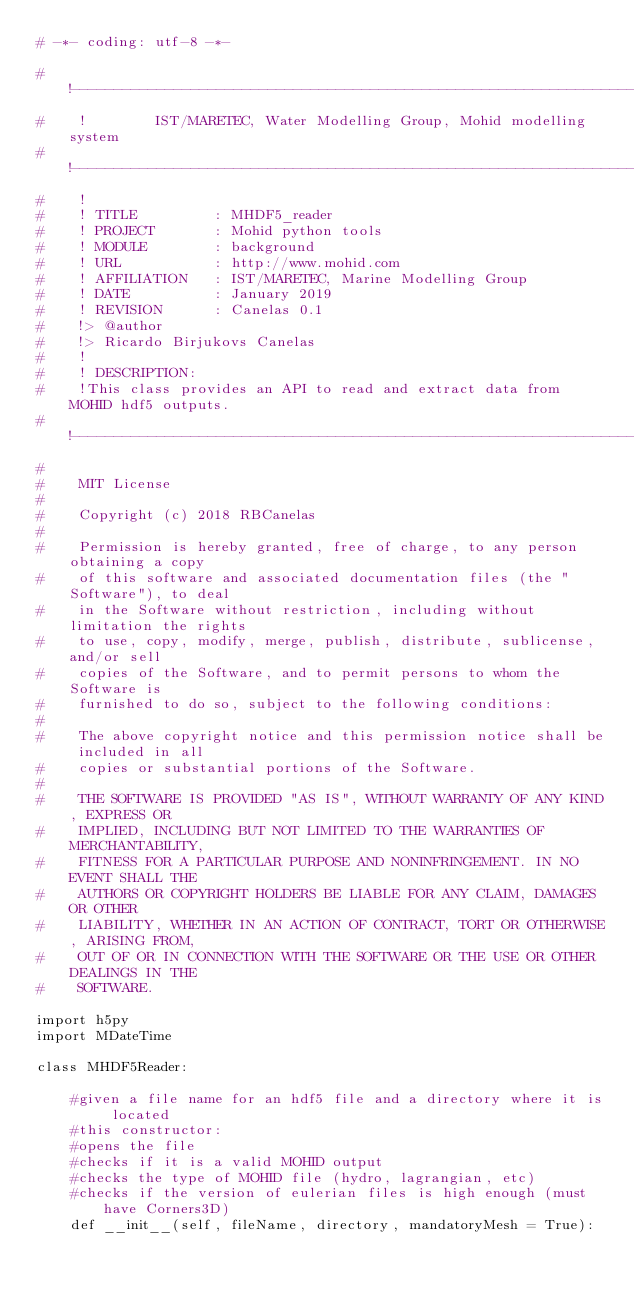Convert code to text. <code><loc_0><loc_0><loc_500><loc_500><_Python_># -*- coding: utf-8 -*-

#    !------------------------------------------------------------------------------
#    !        IST/MARETEC, Water Modelling Group, Mohid modelling system
#    !------------------------------------------------------------------------------
#    !
#    ! TITLE         : MHDF5_reader
#    ! PROJECT       : Mohid python tools
#    ! MODULE        : background
#    ! URL           : http://www.mohid.com
#    ! AFFILIATION   : IST/MARETEC, Marine Modelling Group
#    ! DATE          : January 2019
#    ! REVISION      : Canelas 0.1
#    !> @author
#    !> Ricardo Birjukovs Canelas
#    !
#    ! DESCRIPTION:
#    !This class provides an API to read and extract data from MOHID hdf5 outputs.
#    !------------------------------------------------------------------------------
#    
#    MIT License
#    
#    Copyright (c) 2018 RBCanelas
#    
#    Permission is hereby granted, free of charge, to any person obtaining a copy
#    of this software and associated documentation files (the "Software"), to deal
#    in the Software without restriction, including without limitation the rights
#    to use, copy, modify, merge, publish, distribute, sublicense, and/or sell
#    copies of the Software, and to permit persons to whom the Software is
#    furnished to do so, subject to the following conditions:
#    
#    The above copyright notice and this permission notice shall be included in all
#    copies or substantial portions of the Software.
#    
#    THE SOFTWARE IS PROVIDED "AS IS", WITHOUT WARRANTY OF ANY KIND, EXPRESS OR
#    IMPLIED, INCLUDING BUT NOT LIMITED TO THE WARRANTIES OF MERCHANTABILITY,
#    FITNESS FOR A PARTICULAR PURPOSE AND NONINFRINGEMENT. IN NO EVENT SHALL THE
#    AUTHORS OR COPYRIGHT HOLDERS BE LIABLE FOR ANY CLAIM, DAMAGES OR OTHER
#    LIABILITY, WHETHER IN AN ACTION OF CONTRACT, TORT OR OTHERWISE, ARISING FROM,
#    OUT OF OR IN CONNECTION WITH THE SOFTWARE OR THE USE OR OTHER DEALINGS IN THE
#    SOFTWARE.

import h5py
import MDateTime

class MHDF5Reader:
    
    #given a file name for an hdf5 file and a directory where it is located
    #this constructor: 
    #opens the file
    #checks if it is a valid MOHID output
    #checks the type of MOHID file (hydro, lagrangian, etc)
    #checks if the version of eulerian files is high enough (must have Corners3D) 
    def __init__(self, fileName, directory, mandatoryMesh = True):</code> 